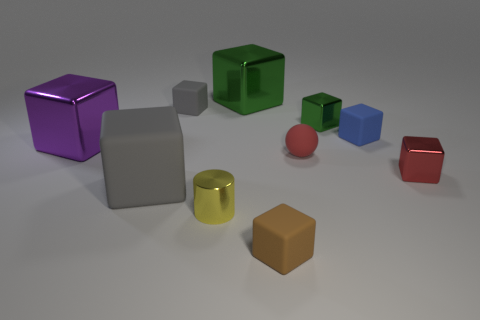The tiny shiny object that is the same color as the ball is what shape?
Your response must be concise. Cube. What color is the large shiny cube right of the gray rubber cube that is in front of the small gray block?
Make the answer very short. Green. Is the material of the small brown object the same as the gray thing in front of the small red block?
Provide a succinct answer. Yes. What material is the big block on the right side of the tiny yellow cylinder?
Ensure brevity in your answer.  Metal. Is the number of tiny brown rubber objects that are behind the brown object the same as the number of large blue cylinders?
Offer a very short reply. Yes. There is a gray object that is in front of the small gray rubber thing behind the big purple shiny cube; what is it made of?
Make the answer very short. Rubber. The big thing that is both behind the red metallic thing and in front of the tiny gray matte block has what shape?
Keep it short and to the point. Cube. There is a red object that is the same shape as the small brown object; what size is it?
Provide a short and direct response. Small. Are there fewer large blocks to the right of the tiny sphere than tiny yellow rubber cylinders?
Provide a short and direct response. No. How big is the matte thing that is in front of the big gray rubber object?
Keep it short and to the point. Small. 